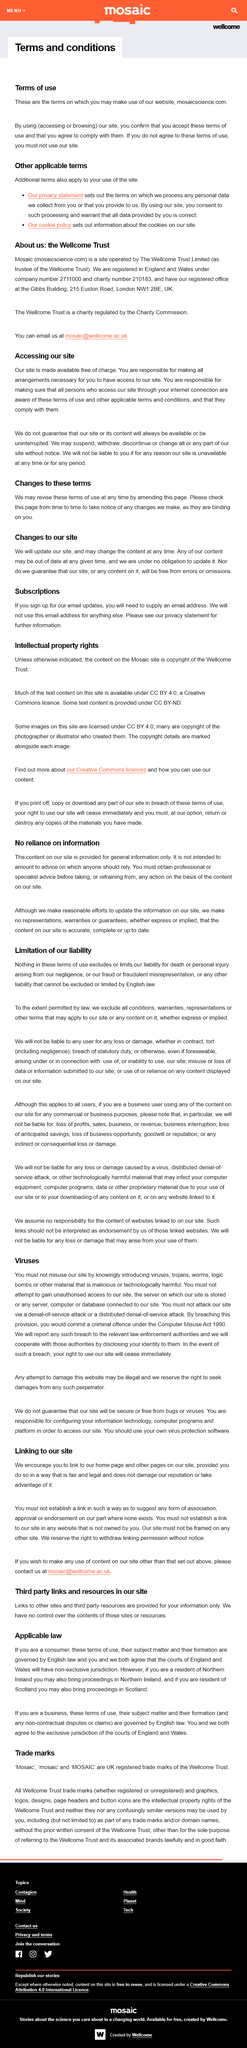Specify some key components in this picture. The article discussed the law of limitation of liability, specifically English law in this case. The site has the ability to withdraw linking permission without prior notice. The user should periodically check the site for any changes to the terms. For businesses, these terms of use are governed by the laws of England. Yes, residents of Northern Ireland can also bring proceedings in Northern Ireland. 